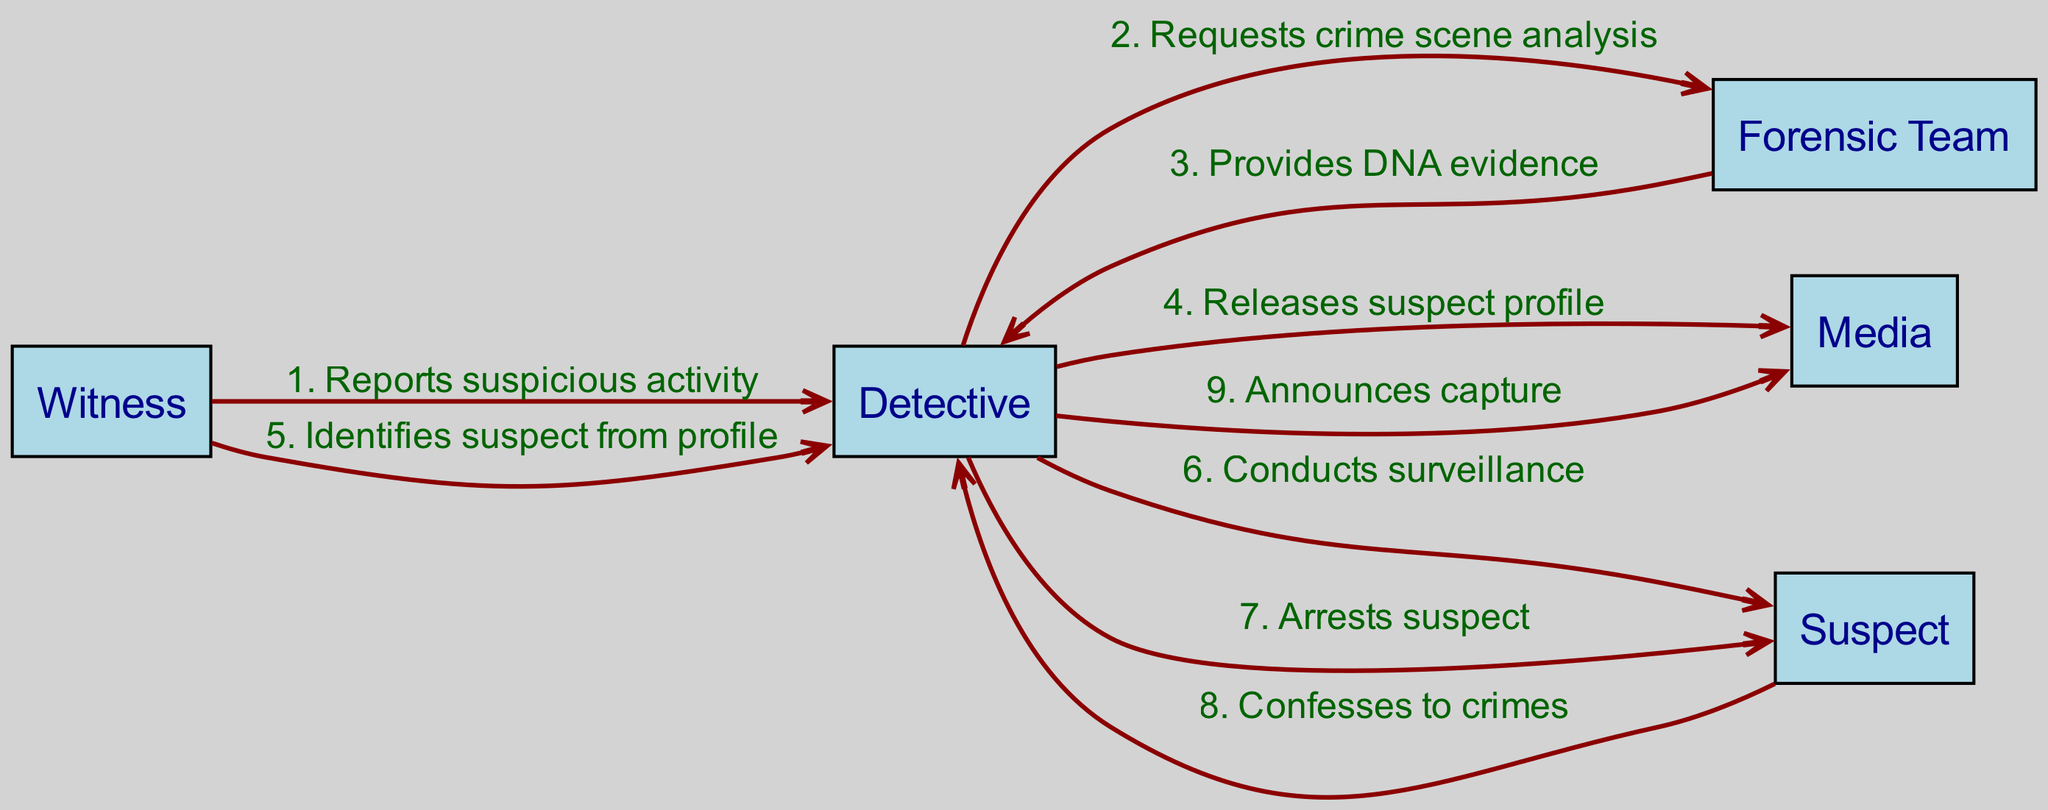What is the total number of actors in this sequence diagram? The sequence diagram lists five unique actors: Detective, Forensic Team, Witness, Media, and Suspect. Counting these, the total number of actors is five.
Answer: 5 Who reports suspicious activity to the Detective? Looking at the sequence, the first event shows that the Witness is the one who reports suspicious activity directly to the Detective.
Answer: Witness What message does the Forensic Team provide to the Detective? The Forensic Team responds to the Detective with the message "Provides DNA evidence", as noted in the third event of the sequence.
Answer: Provides DNA evidence Which actor identifies the suspect from the profile released by the Detective? The sequence indicates that the Witness is the actor who identifies the suspect from the profile released by the Detective, as seen in the fifth event.
Answer: Witness How many actions occur between the Detective and the Suspect? Observing the diagram, there are two distinct actions: one for surveillance and another for the arrest. These are the sixth and seventh events in the sequence.
Answer: 2 What does the Detective announce to the Media after the capture? The Detective announces the "capture" to the Media as noted in the last event of the sequence, which marks the conclusion of the capture.
Answer: Capture What does the Suspect do after being arrested? After the arrest, the Suspect confesses to crimes, which is indicated in the eighth event of the sequence, showing an immediate response to the arrest.
Answer: Confesses to crimes What triggers the Detective to release the suspect profile? Based on the flow of information, the Detective releases the suspect profile after getting DNA evidence from the Forensic Team, as indicated in the second and fourth events.
Answer: DNA evidence Which actor receives the DNA evidence? The diagram shows that the Forensic Team provides DNA evidence directly to the Detective following the request made by the Detective.
Answer: Detective 